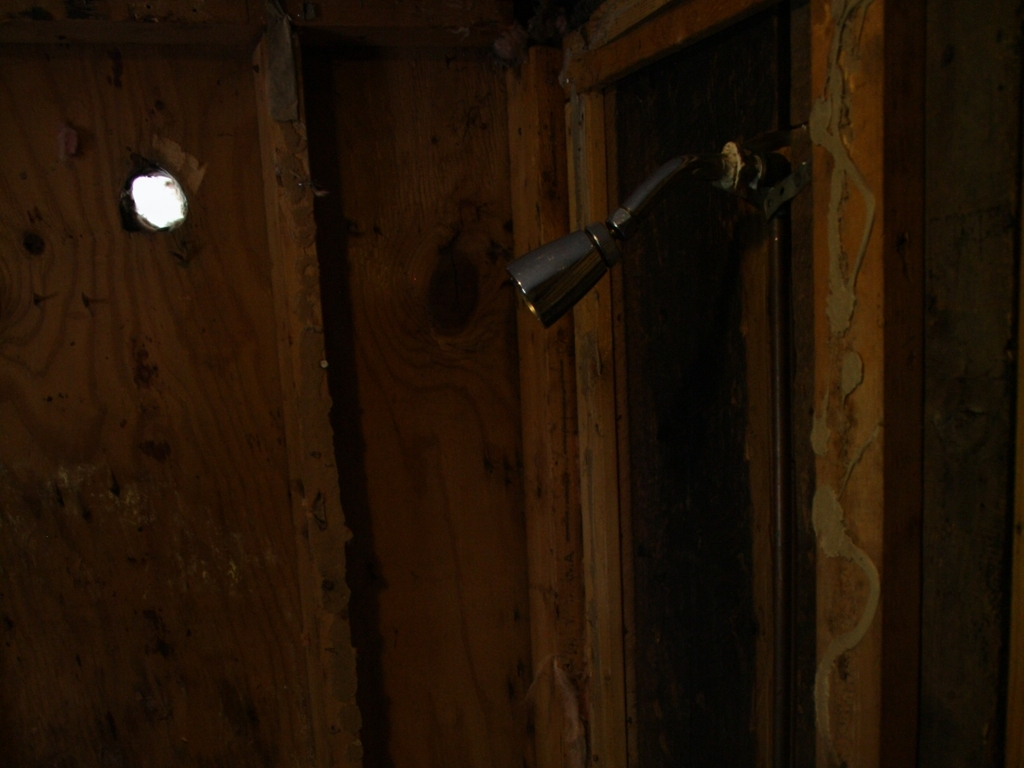Could this setting be part of a larger story or theme? Indeed, the setting could easily be woven into a narrative of abandonment or transformation. One could imagine it as a forgotten area in a once-busy household, now standing quiet and untouched. Alternatively, it could symbolize a phase of transition, where the old is being cleared to make room for the new. 